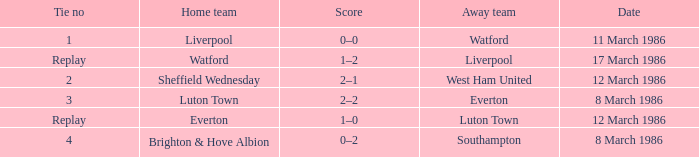Help me parse the entirety of this table. {'header': ['Tie no', 'Home team', 'Score', 'Away team', 'Date'], 'rows': [['1', 'Liverpool', '0–0', 'Watford', '11 March 1986'], ['Replay', 'Watford', '1–2', 'Liverpool', '17 March 1986'], ['2', 'Sheffield Wednesday', '2–1', 'West Ham United', '12 March 1986'], ['3', 'Luton Town', '2–2', 'Everton', '8 March 1986'], ['Replay', 'Everton', '1–0', 'Luton Town', '12 March 1986'], ['4', 'Brighton & Hove Albion', '0–2', 'Southampton', '8 March 1986']]} What was the tie involving southampton? 4.0. 